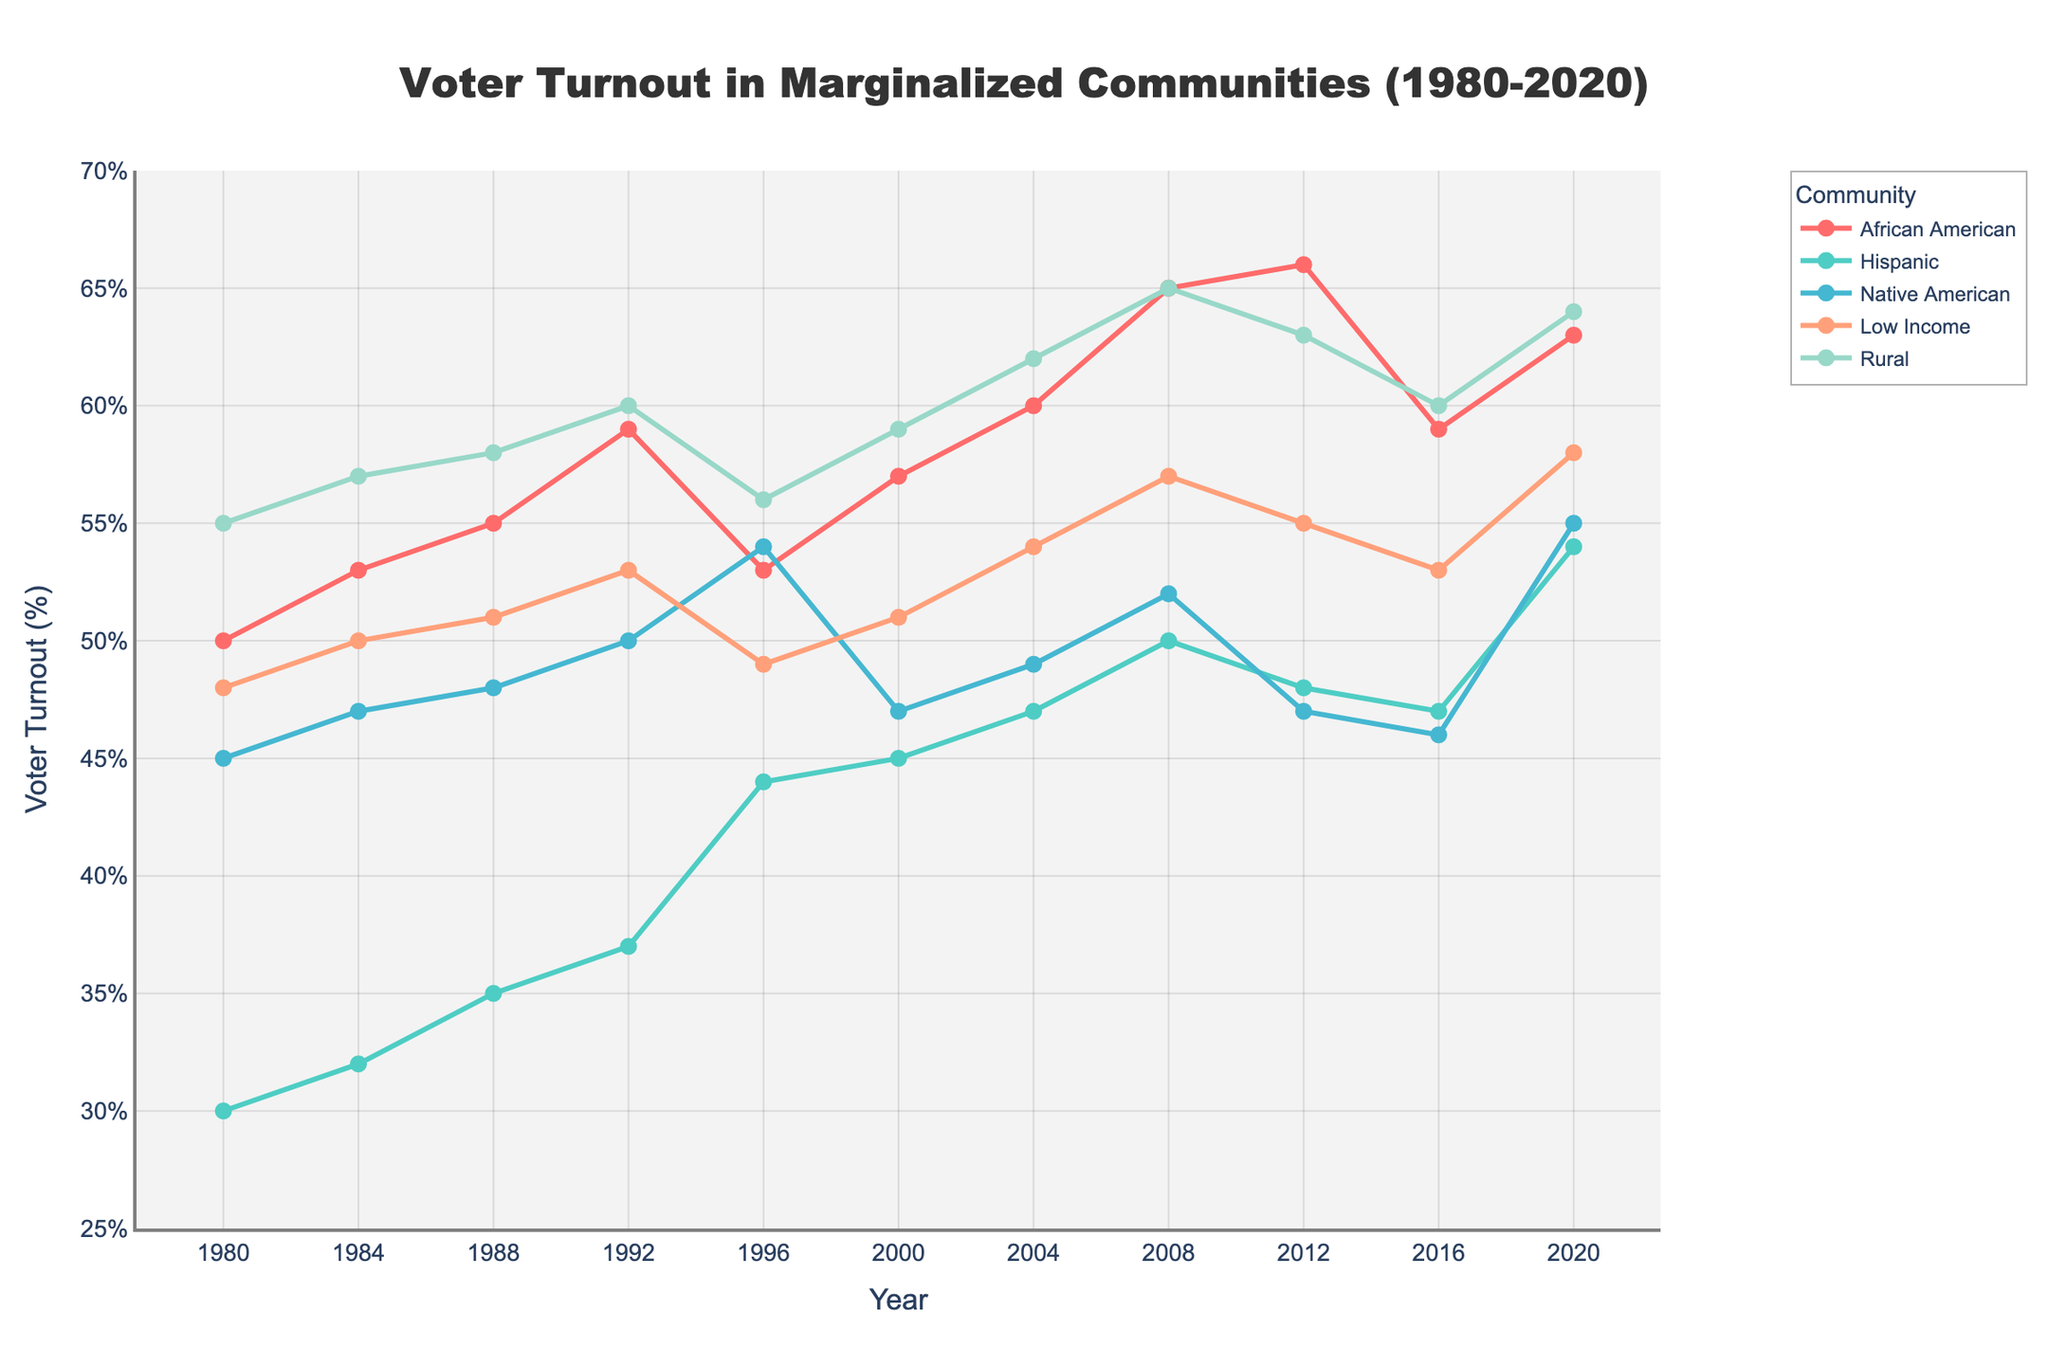What year shows the highest voter turnout among African Americans? First, look at the line corresponding to African American voter turnout, which is marked with a red line. Identify the peak point on this line, and trace it back to the corresponding year on the x-axis. The highest point on this line is in the year 2012.
Answer: 2012 In which year was the difference between Hispanic and Native American voter turnout the greatest? Look at both the green line (Hispanic) and the blue line (Native American). Calculate the differences for each year. The biggest gap is in 2020 when Hispanic turnout is 54% and Native American turnout is 55%, giving a difference of 9%.
Answer: 2020 Which community experienced the most significant improvement in voter turnout between 1980 and 2020? Find the starting point (1980) and ending point (2020) for each line representing the different communities. Calculate the difference for each community. Hispanic community starts at 30% and ends at 54%, gaining 24 percentage points, which is the highest increase.
Answer: Hispanic What is the average voter turnout for the Low Income community across all years? Sum the voter turnout percentages for Low Income from 1980 to 2020 and divide by the number of years (which is 11). (48+50+51+53+49+51+54+57+55+53+58) / 11 = approximately 52.09.
Answer: 52.09% Between 2008 and 2012, which community saw a decline in voter turnout? Compare the voter turnout values for each community in 2008 and 2012. African American (65% to 66%), Hispanic (50% to 48%), Native American (52% to 47%), Low Income (57% to 55%), and Rural (65% to 63%). Native American voter turnout decreased from 52% to 47%.
Answer: Native American Which year had the lowest overall voter turnout for Rural communities? Look for the minimum point on the line representing Rural communities, marked by the orange line. The lowest point is in 1980, with a turnout of 55%.
Answer: 1980 How did the voter turnout for African American and Low Income communities compare in 2000? Identify the points on the graph for the African American (57%) and Low Income (51%) communities in 2000. Comparing these, African American turnout is higher than Low Income by 6%.
Answer: African American turnout was higher by 6% From 1980 to 2004, which community showed the least overall change in voter turnout? Calculate the difference between the voter turnout in 1980 and 2004 for each community. African American (50% to 60%, +10%), Hispanic (30% to 47%, +17%), Native American (45% to 49%, +4%), Low Income (48% to 54%, +6%), and Rural (55% to 62%, +7%). Native American community had the least change (+4%).
Answer: Native American What is the average voter turnout change for all communities between 2016 and 2020? Calculate the changes for each community between 2016 and 2020: African American (+4), Hispanic (+7), Native American (+9), Low Income (+5), Rural (+4). Then, sum these changes and divide by 5: (4 + 7 + 9 + 5 + 4) / 5 = 5.8.
Answer: 5.8% 